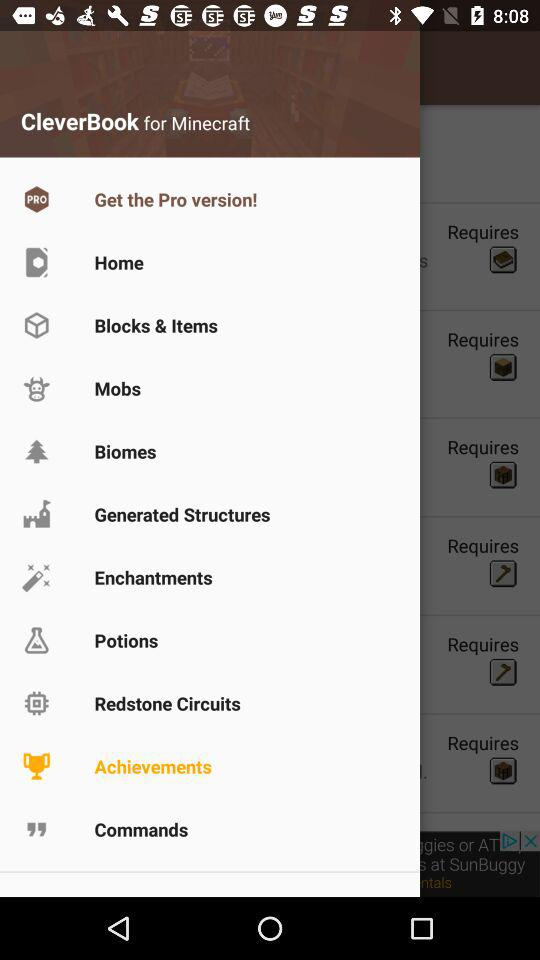Which item is selected? The selected item is "Achievements". 